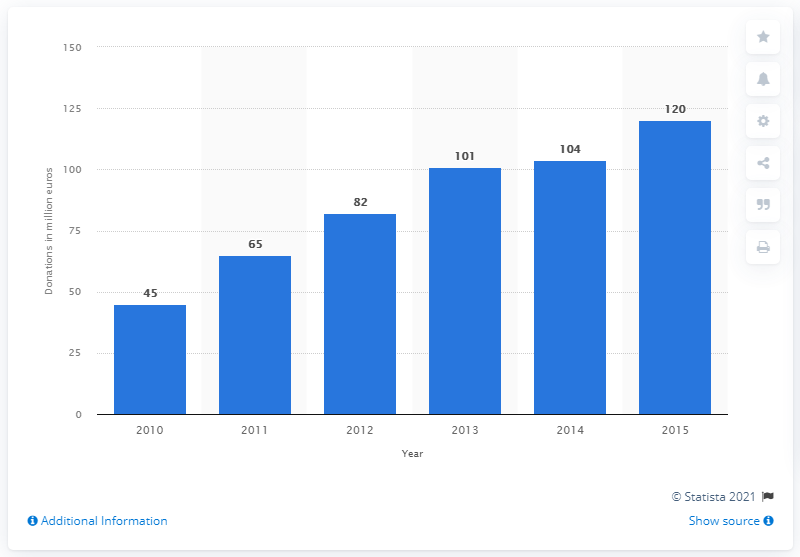Indicate a few pertinent items in this graphic. IKEA Foundation donated $101 million to support children in 2013. 